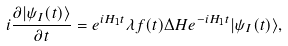Convert formula to latex. <formula><loc_0><loc_0><loc_500><loc_500>i \frac { \partial | \psi _ { I } ( t ) \rangle } { \partial t } = e ^ { i H _ { 1 } t } \lambda f ( t ) \Delta H e ^ { - i H _ { 1 } t } | \psi _ { I } ( t ) \rangle ,</formula> 